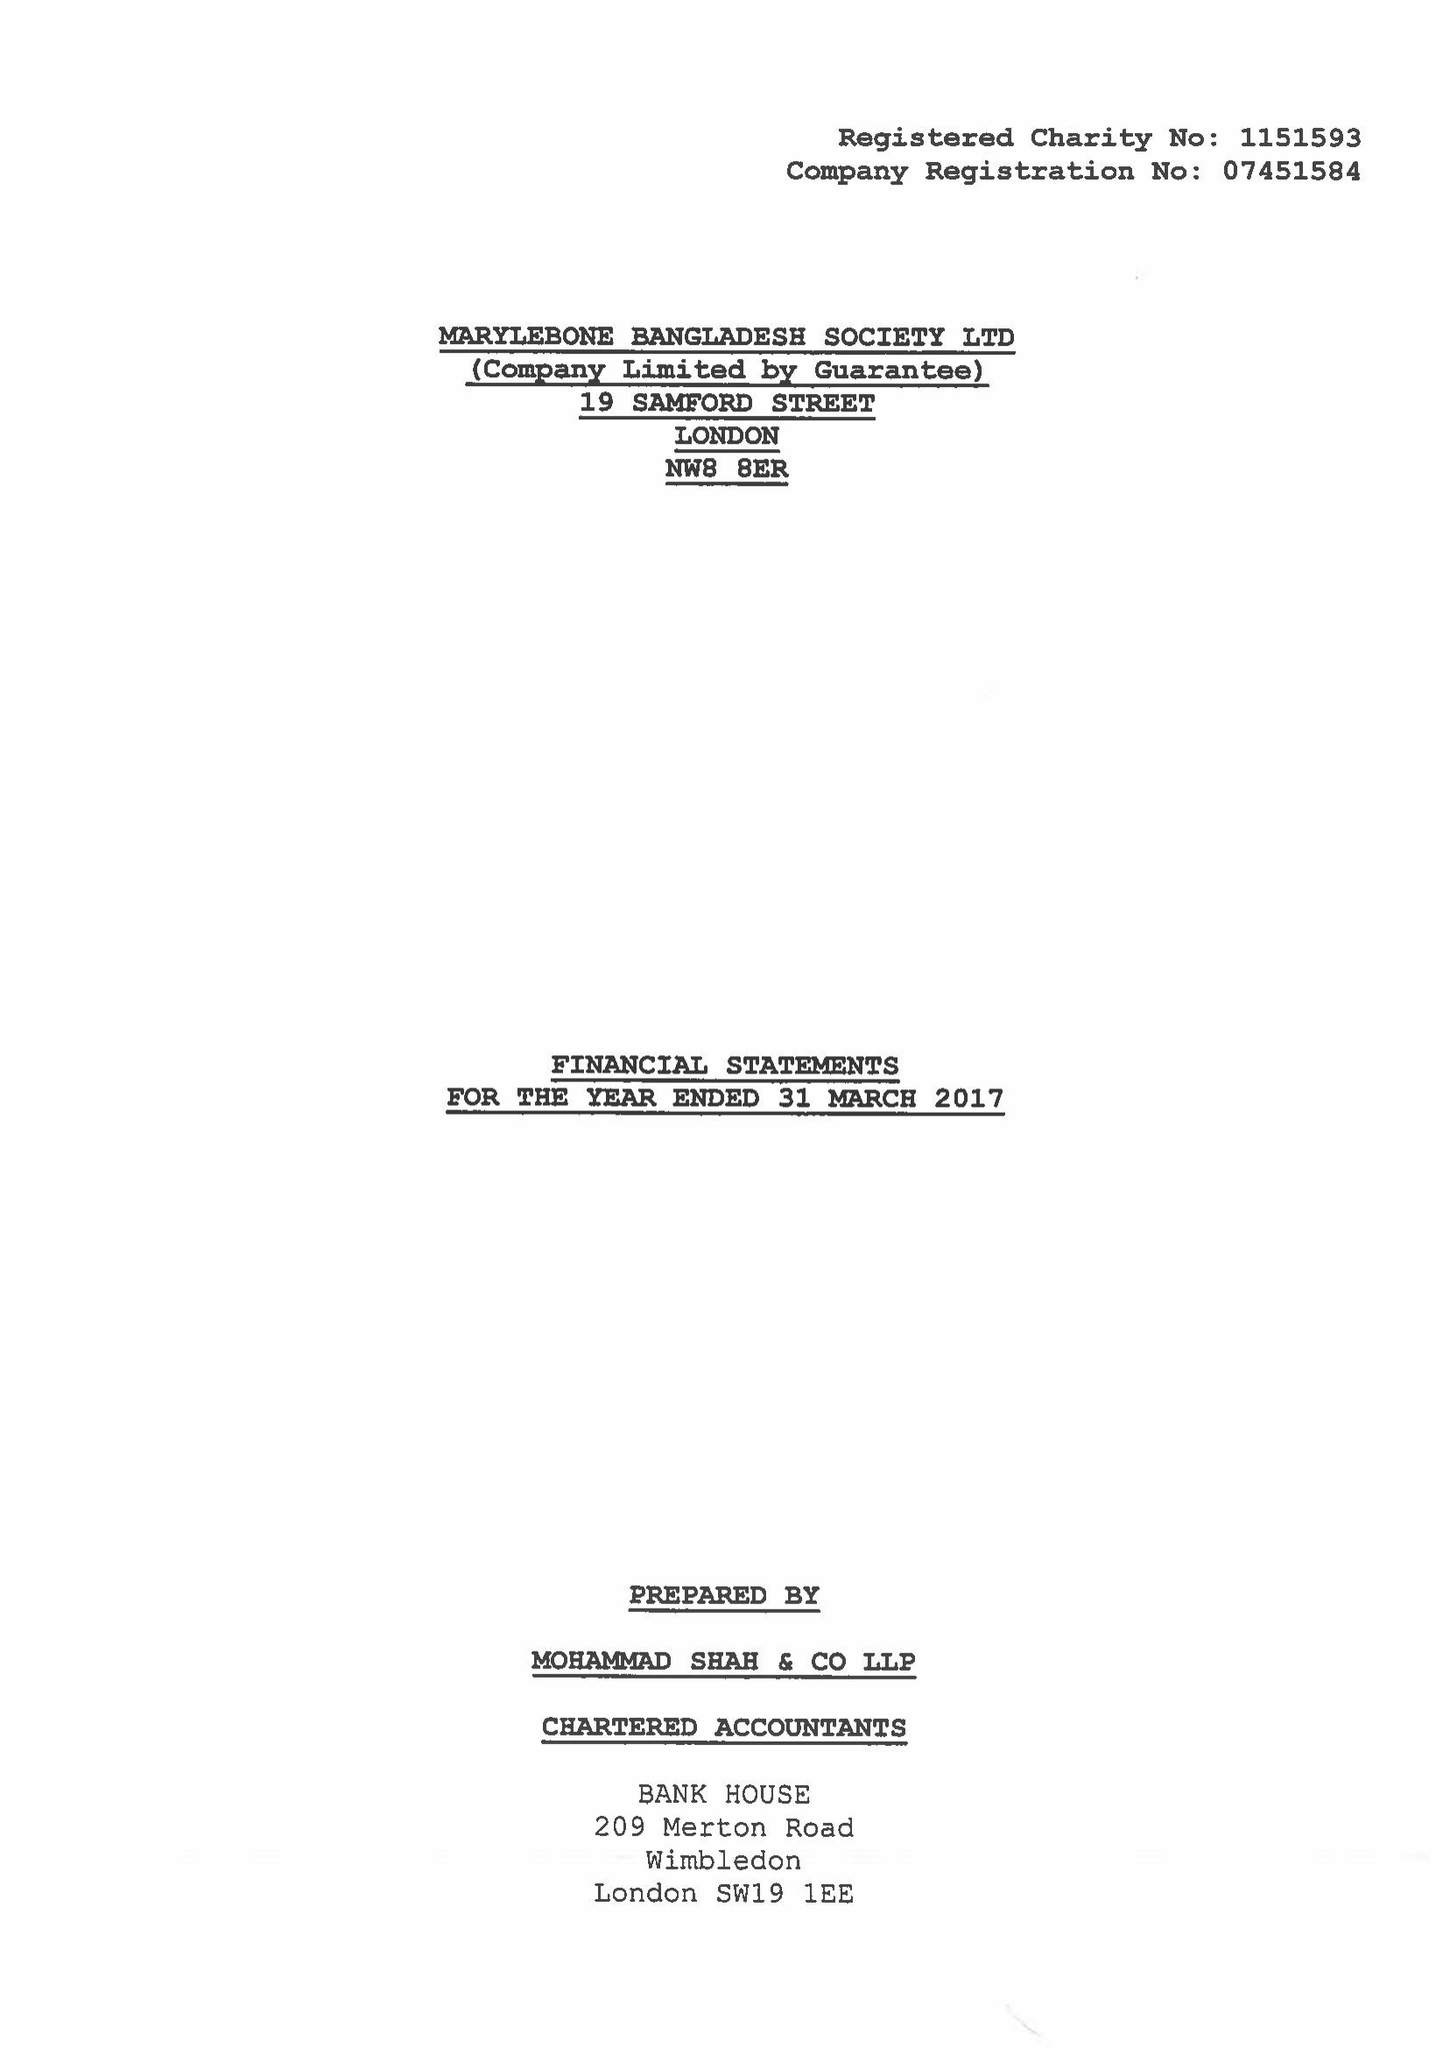What is the value for the address__post_town?
Answer the question using a single word or phrase. LONDON 